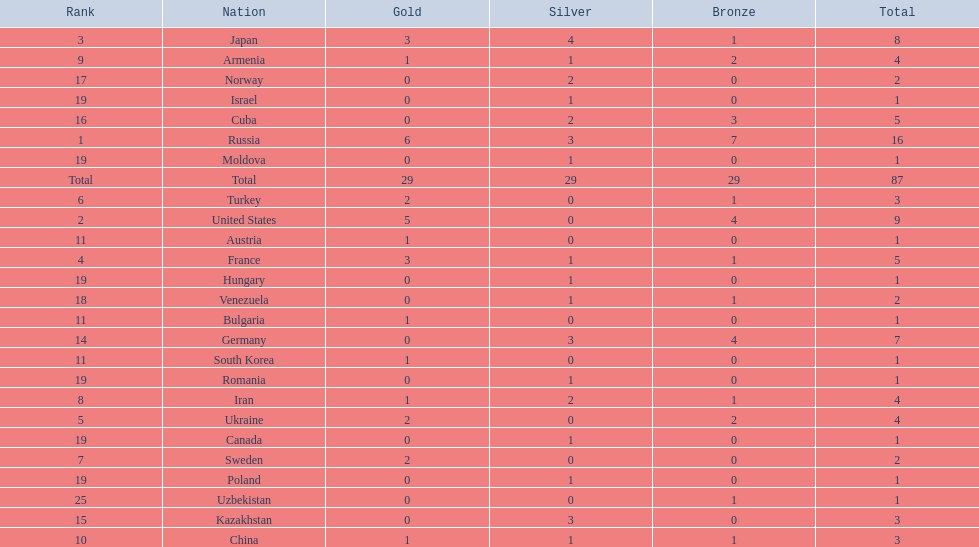How many gold medals did the united states win? 5. Who won more than 5 gold medals? Russia. 